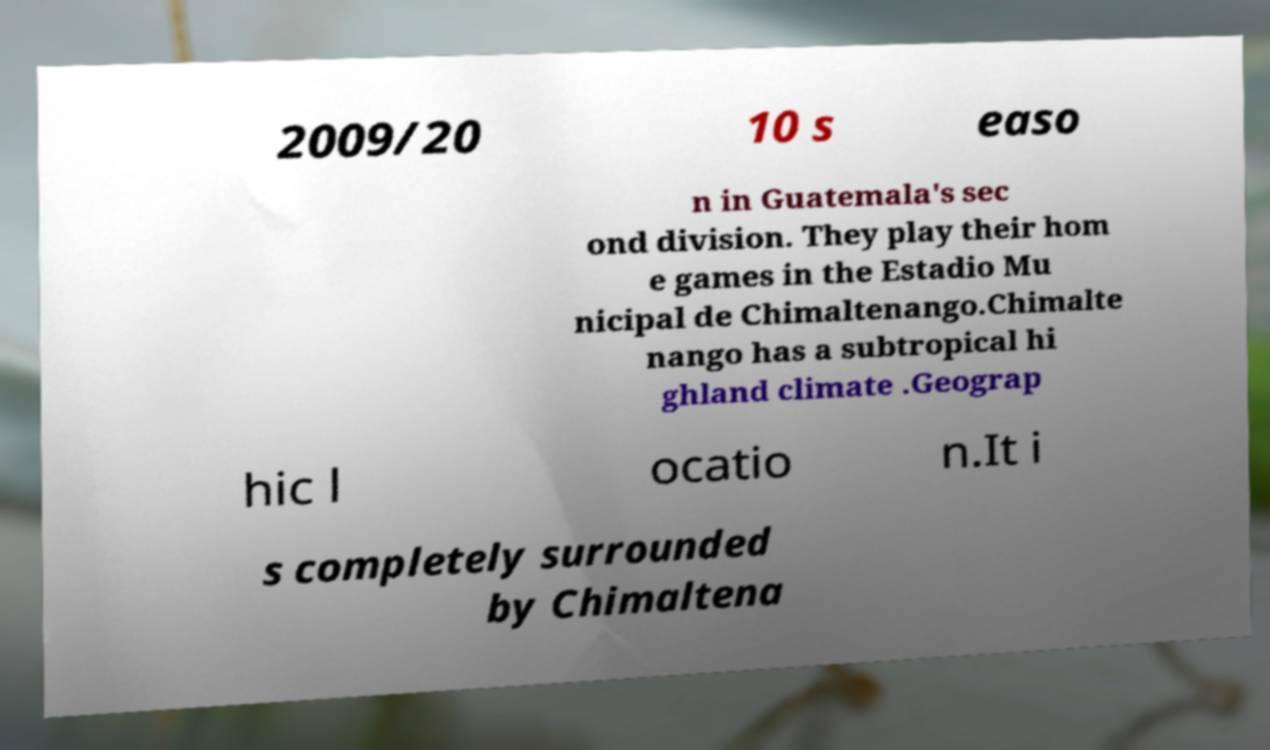What messages or text are displayed in this image? I need them in a readable, typed format. 2009/20 10 s easo n in Guatemala's sec ond division. They play their hom e games in the Estadio Mu nicipal de Chimaltenango.Chimalte nango has a subtropical hi ghland climate .Geograp hic l ocatio n.It i s completely surrounded by Chimaltena 